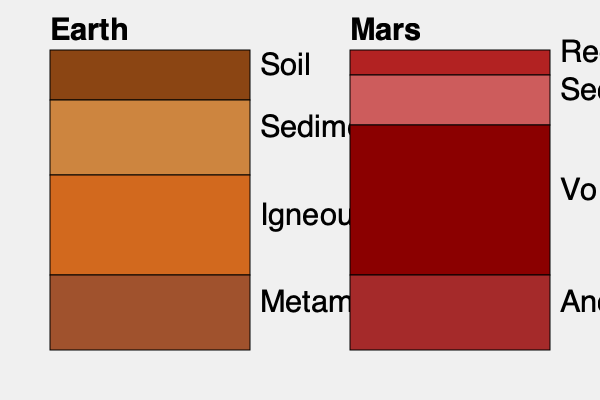Based on the cross-sectional diagrams of Earth and Mars stratigraphy, which key difference in geological processes between the two planets is most evident, and how might this challenge current interpretations of Martian geological history? To answer this question, we need to analyze the stratigraphic columns for both Earth and Mars:

1. Earth's stratigraphy:
   a) Top layer: Soil
   b) Second layer: Sedimentary rocks
   c) Third layer: Igneous rocks
   d) Bottom layer: Metamorphic rocks

2. Mars' stratigraphy:
   a) Top layer: Regolith
   b) Second layer: Sedimentary rocks
   c) Third layer: Volcanic rocks
   d) Bottom layer: Ancient crust

3. Key differences:
   a) Earth has a distinct metamorphic layer, while Mars does not.
   b) Mars has a larger proportion of volcanic rocks compared to Earth.
   c) Earth's top layer is soil, while Mars has regolith.

4. Implications for geological processes:
   a) The absence of a metamorphic layer on Mars suggests a lack of plate tectonics and associated heat and pressure.
   b) The larger volcanic layer on Mars indicates more extensive and prolonged volcanic activity.
   c) The presence of regolith instead of soil on Mars suggests different weathering processes and lack of organic material.

5. Challenging current interpretations:
   a) The absence of metamorphic rocks challenges the idea of past plate tectonics on Mars.
   b) The extensive volcanic layer may indicate longer-lasting volcanic activity than previously thought.
   c) The thin sedimentary layer questions the extent and duration of water-related processes on Mars.

These differences suggest that Mars has experienced a significantly different geological history compared to Earth, with less tectonic activity, more volcanism, and limited water-related processes. This challenges interpretations that assume Earth-like geological processes on Mars and requires a re-evaluation of Martian geological history.
Answer: Lack of metamorphic rocks on Mars, indicating absence of plate tectonics and challenging assumptions of Earth-like geological processes. 